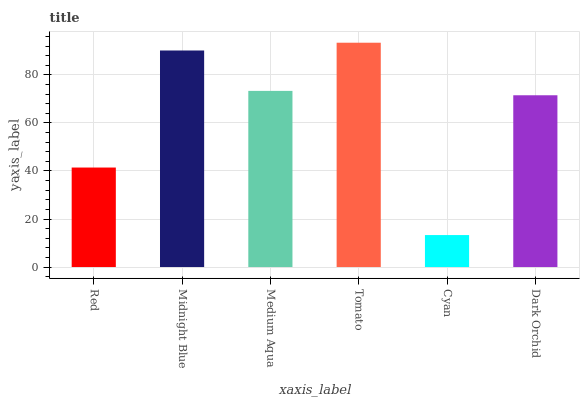Is Cyan the minimum?
Answer yes or no. Yes. Is Tomato the maximum?
Answer yes or no. Yes. Is Midnight Blue the minimum?
Answer yes or no. No. Is Midnight Blue the maximum?
Answer yes or no. No. Is Midnight Blue greater than Red?
Answer yes or no. Yes. Is Red less than Midnight Blue?
Answer yes or no. Yes. Is Red greater than Midnight Blue?
Answer yes or no. No. Is Midnight Blue less than Red?
Answer yes or no. No. Is Medium Aqua the high median?
Answer yes or no. Yes. Is Dark Orchid the low median?
Answer yes or no. Yes. Is Midnight Blue the high median?
Answer yes or no. No. Is Red the low median?
Answer yes or no. No. 